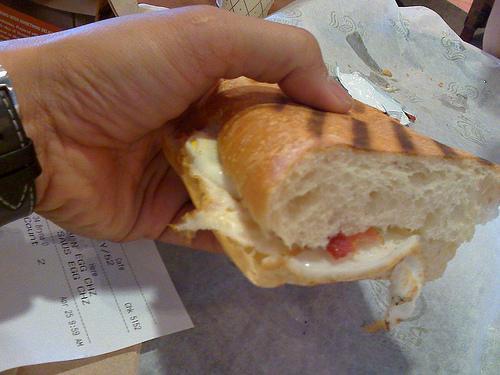How many hands are shown?
Give a very brief answer. 1. 